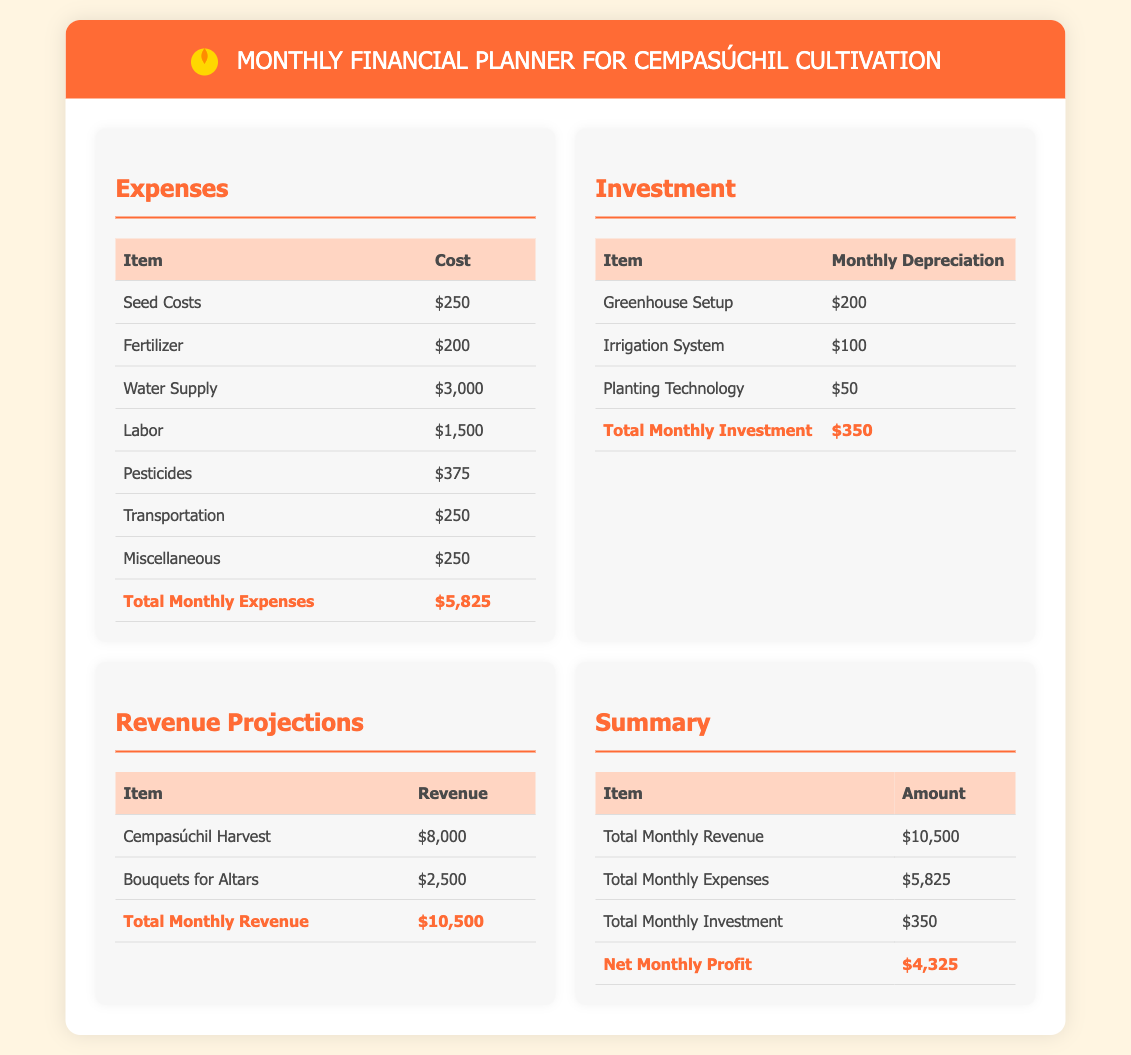What is the total monthly expense? The total monthly expense is listed at the bottom of the expenses table.
Answer: $5,825 What is the cost of water supply? The cost of water supply is found in the expenses table.
Answer: $3,000 What is the total monthly revenue? The total monthly revenue is provided at the end of the revenue projections table.
Answer: $10,500 How much is allocated for labor? Labor costs can be found in the expenses section of the document.
Answer: $1,500 What is the monthly depreciation for the irrigation system? The monthly depreciation for the irrigation system is shown in the investment table.
Answer: $100 What is the net monthly profit? The net monthly profit is calculated based on the total revenue, expenses, and investments presented in the summary.
Answer: $4,325 What are bouquets for altars projected to earn? The revenue from bouquets for altars can be found in the revenue projections section.
Answer: $2,500 What is the total monthly investment? The total monthly investment is at the bottom of the investment table, indicating overall investment costs.
Answer: $350 What is the cost of pesticides? The cost of pesticides is detailed in the expenses section of the document.
Answer: $375 